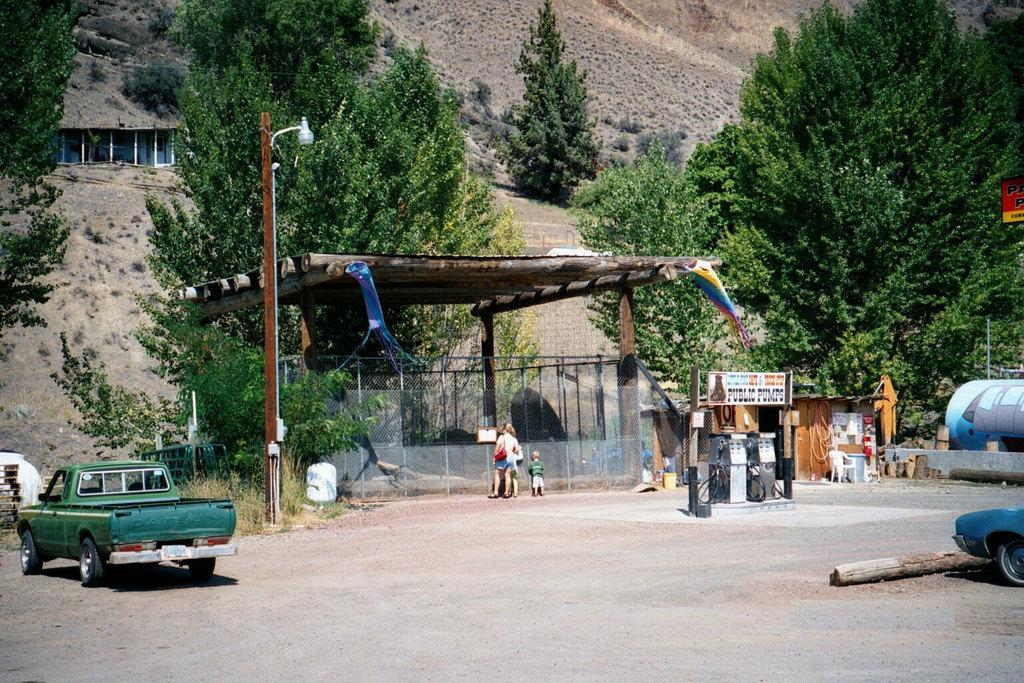In one or two sentences, can you explain what this image depicts? This image is taken outdoors. At the bottom of the image there is a road. In the background there is a ground with a few trees and plants on it. There is a hut with a roof and walls. In the middle of the image there is a cabin with a mesh and a roof. There are a few iron bars. There is a pole with a street light. A woman and two kids are standing on the road. On the left side of the image a car is parked on the road. On the right side of the image there are two boards with a text on them and there is a cabin. There is an empty chair and a car is parked on the road. There is a bark of a tree. 